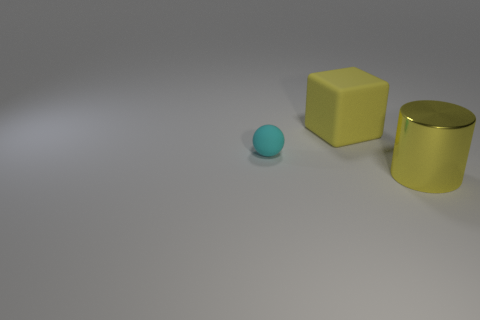Are the small cyan ball and the yellow cylinder made of the same material?
Keep it short and to the point. No. Is there a cyan matte object that has the same shape as the big yellow matte thing?
Offer a very short reply. No. Do the matte thing that is on the right side of the small sphere and the big metal thing have the same color?
Offer a very short reply. Yes. Does the ball that is left of the big metallic object have the same size as the yellow thing that is behind the big metallic cylinder?
Your response must be concise. No. There is a cube that is made of the same material as the cyan sphere; what is its size?
Keep it short and to the point. Large. How many objects are to the left of the yellow block and to the right of the cube?
Make the answer very short. 0. How many objects are yellow rubber things or yellow rubber cubes that are behind the yellow cylinder?
Make the answer very short. 1. The matte thing that is the same color as the large metal object is what shape?
Offer a terse response. Cube. There is a small object in front of the rubber cube; what color is it?
Your answer should be compact. Cyan. What number of things are large objects that are behind the tiny thing or small blue metal cubes?
Ensure brevity in your answer.  1. 